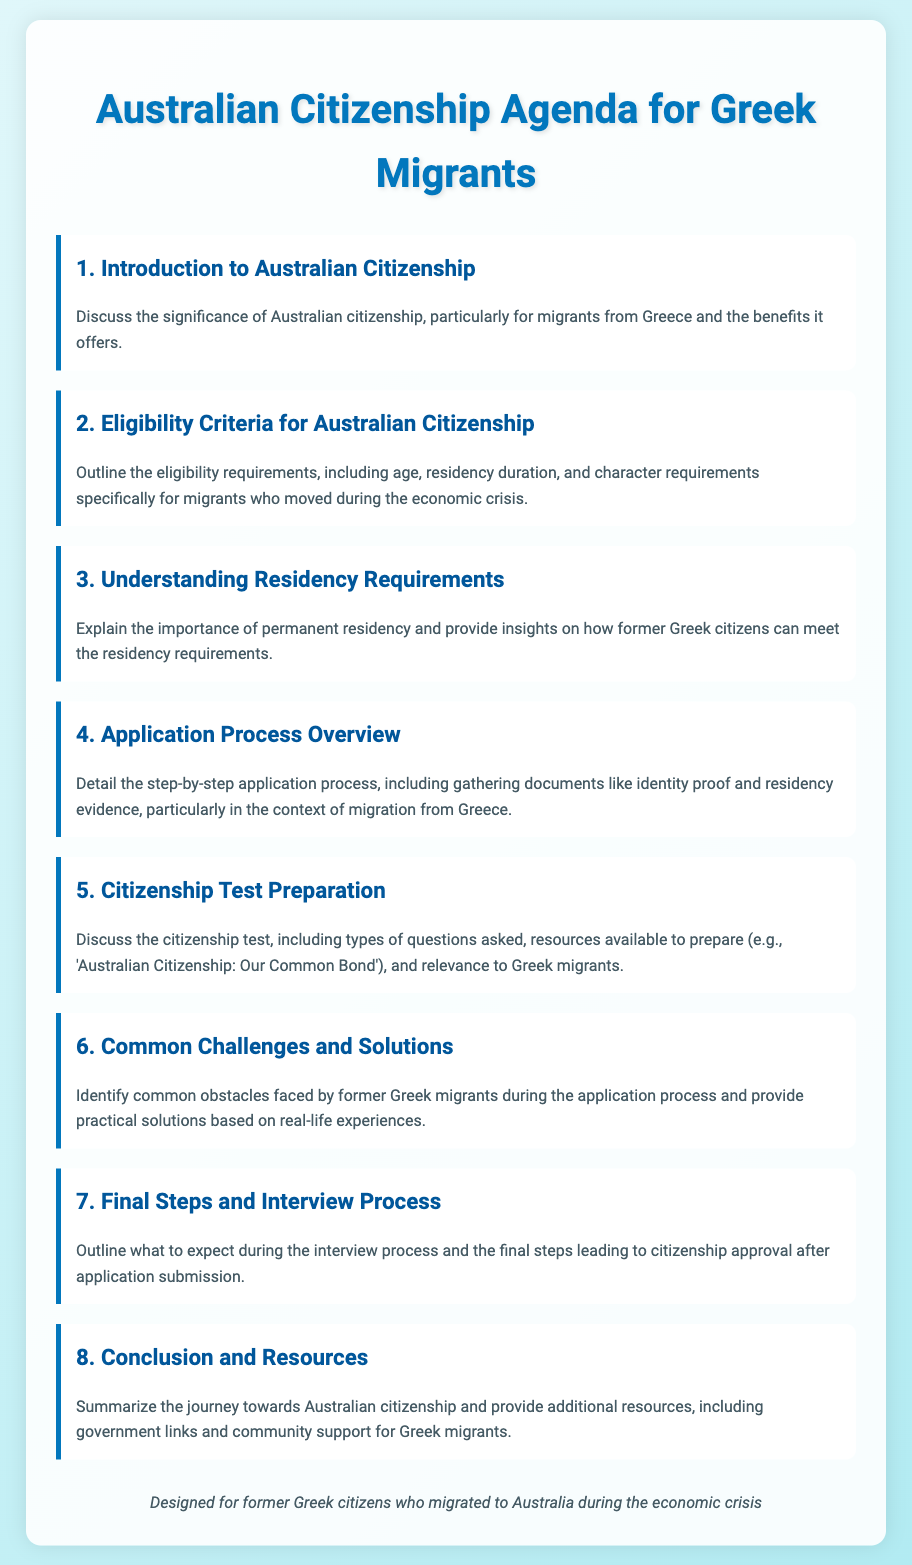what is the title of the document? The title is displayed prominently at the top of the agenda, summarizing its focus on citizenship for a specific migrant group.
Answer: Australian Citizenship Agenda for Greek Migrants what is discussed in the first agenda item? The first agenda item outlines the general significance of Australian citizenship and its benefits for the targeted migrant group.
Answer: Significance of Australian citizenship how many agenda items are there? The total number of agenda items can be determined by counting the sections listed in the document.
Answer: Eight what is a requirement mentioned in the eligibility criteria? Specific criteria outlined for citizenship eligibility are highlighted in section two of the document.
Answer: Character requirements which document is recommended for citizenship test preparation? The recommended resource for preparing for the citizenship test is stated in the citizenship test preparation section.
Answer: Australian Citizenship: Our Common Bond what kind of challenges are identified in the common challenges section? This section focuses on the difficulties specifically faced by former Greek migrants during the application process.
Answer: Common obstacles what is the final step mentioned in the document? The final step towards citizenship approval is mentioned in the last agenda item, summarizing the process.
Answer: Citizenship approval who is the intended audience for the document? The footer provides a clear indication of the group this document is specifically designed for, highlighting its target audience.
Answer: Former Greek citizens 